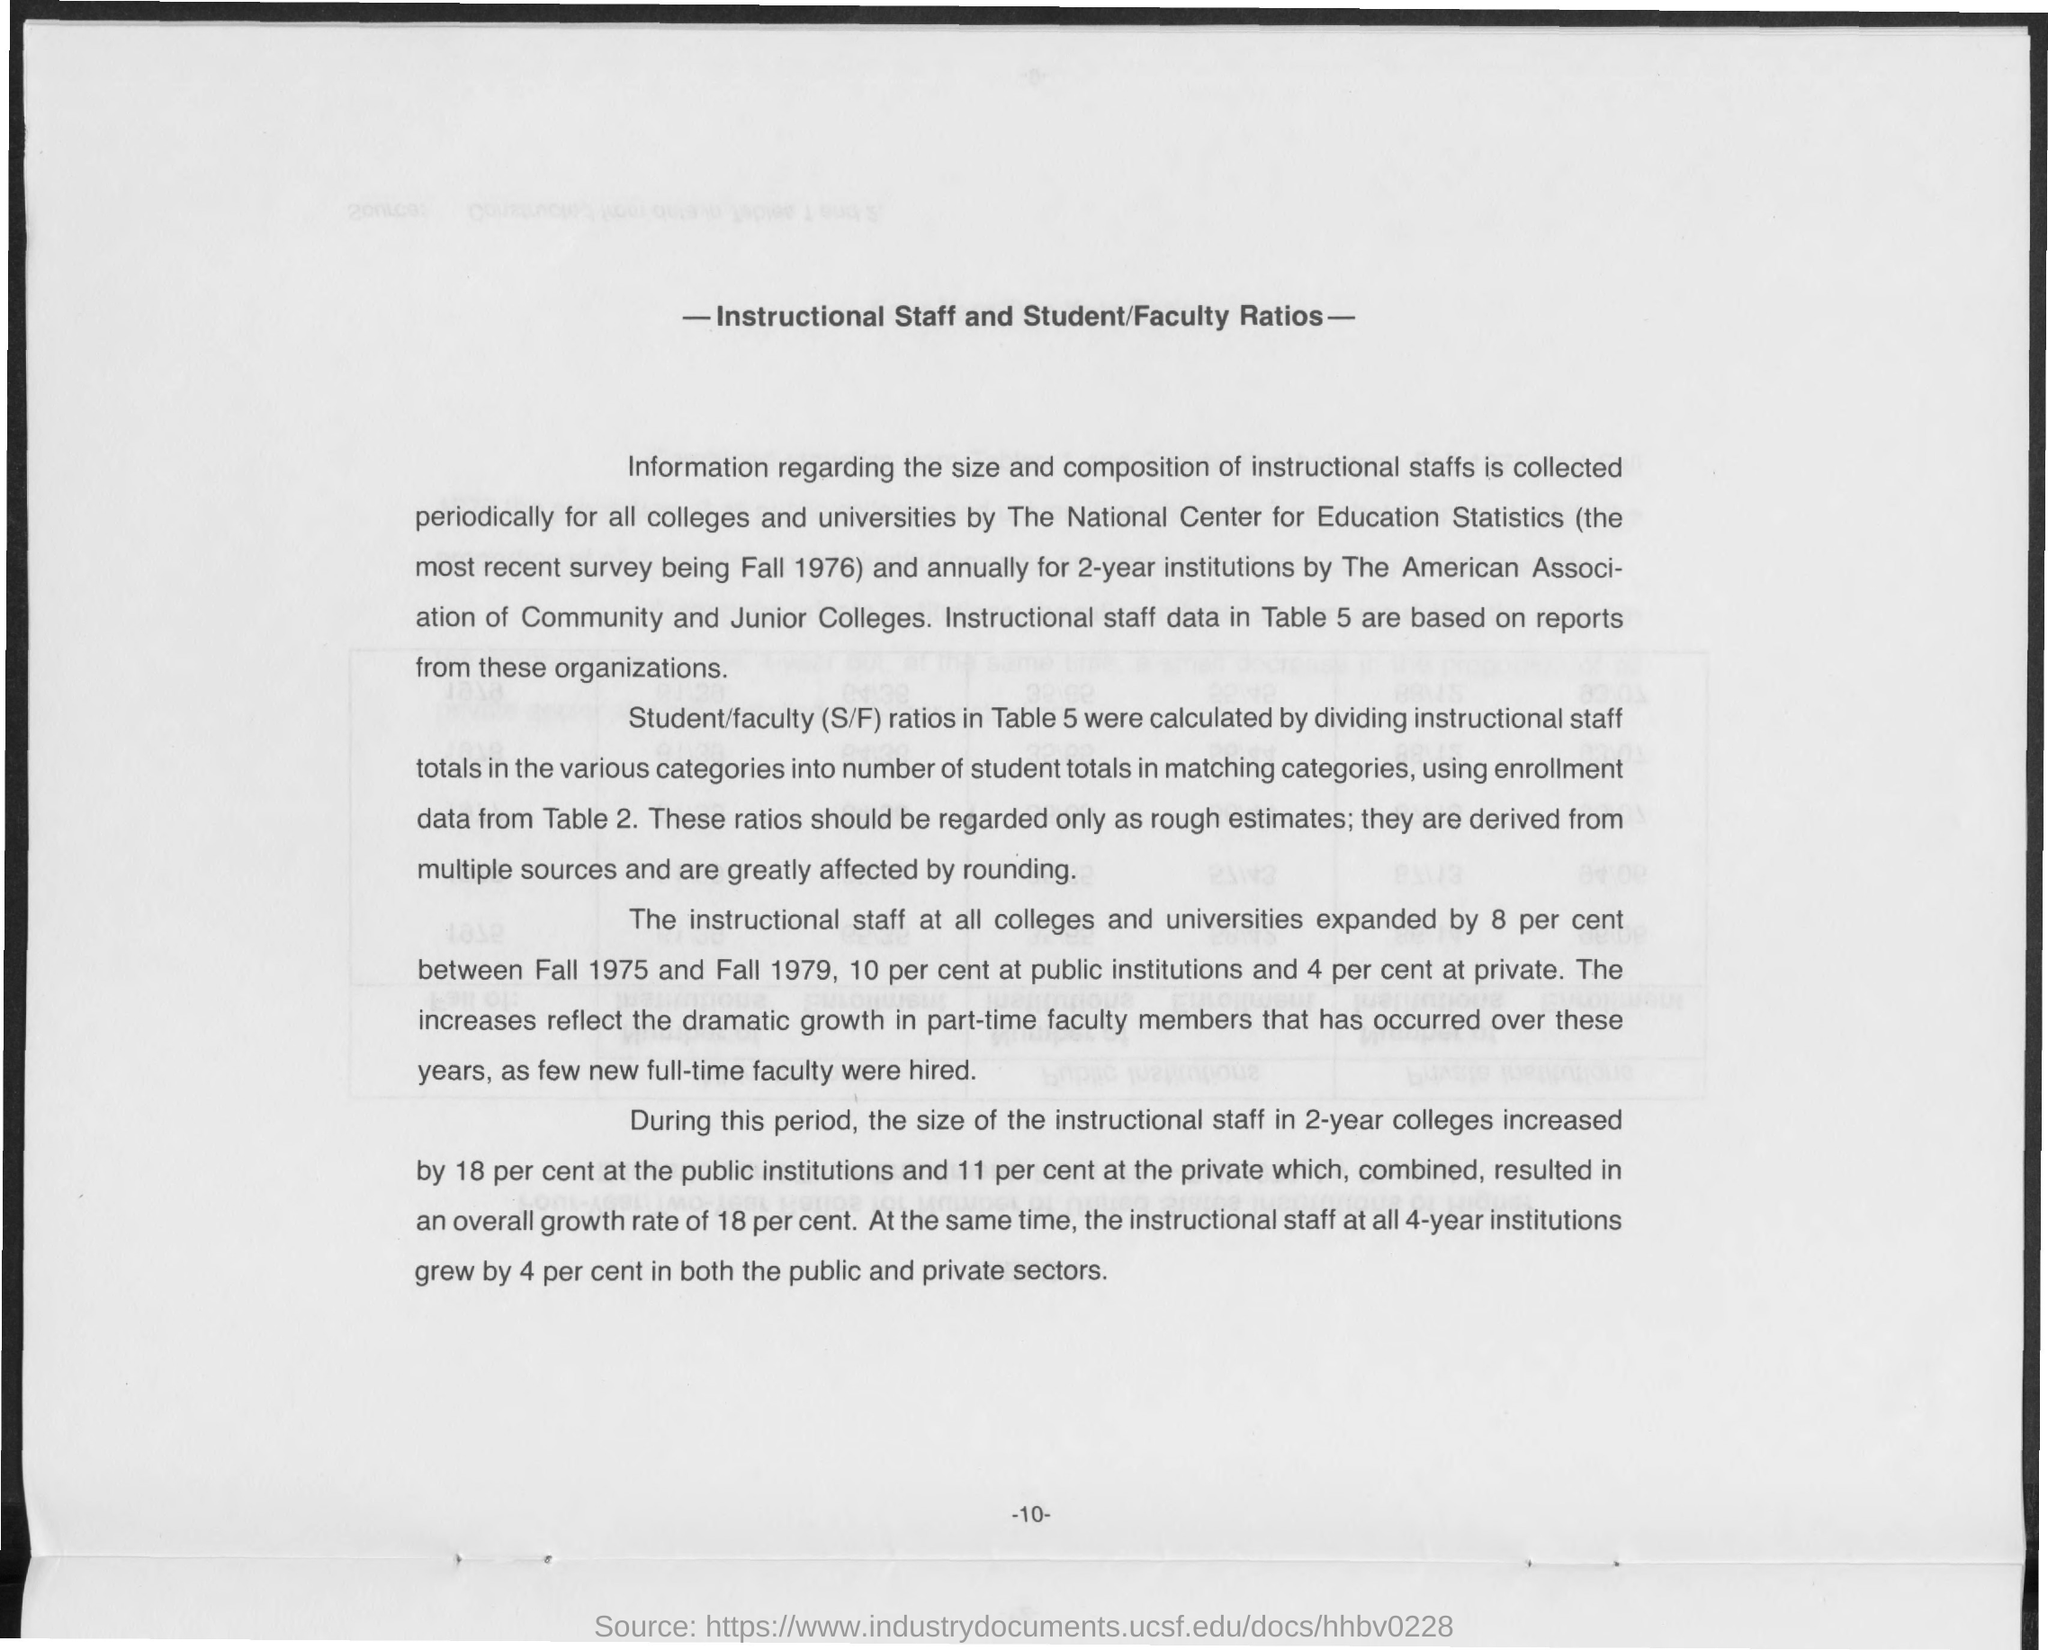What is the title of the document?
Provide a succinct answer. -Instructional Staff and Student/Faculty Ratios-. 